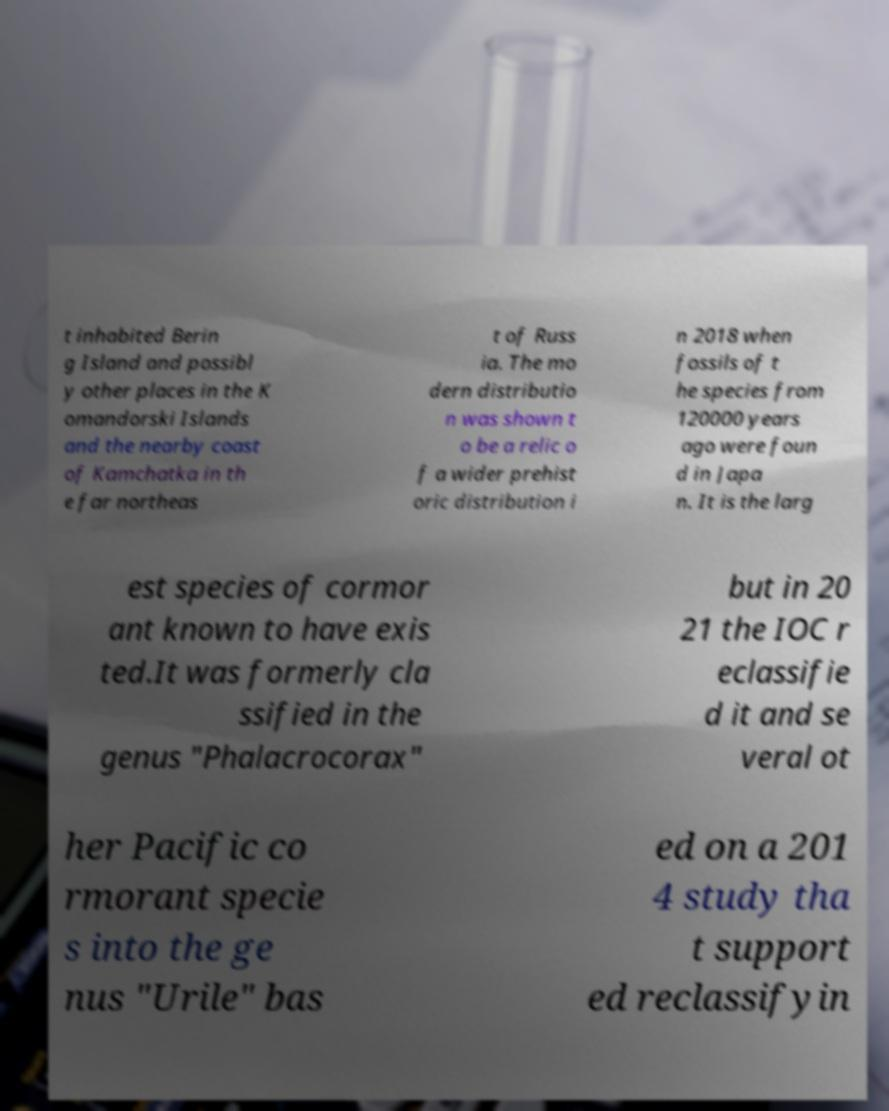I need the written content from this picture converted into text. Can you do that? t inhabited Berin g Island and possibl y other places in the K omandorski Islands and the nearby coast of Kamchatka in th e far northeas t of Russ ia. The mo dern distributio n was shown t o be a relic o f a wider prehist oric distribution i n 2018 when fossils of t he species from 120000 years ago were foun d in Japa n. It is the larg est species of cormor ant known to have exis ted.It was formerly cla ssified in the genus "Phalacrocorax" but in 20 21 the IOC r eclassifie d it and se veral ot her Pacific co rmorant specie s into the ge nus "Urile" bas ed on a 201 4 study tha t support ed reclassifyin 